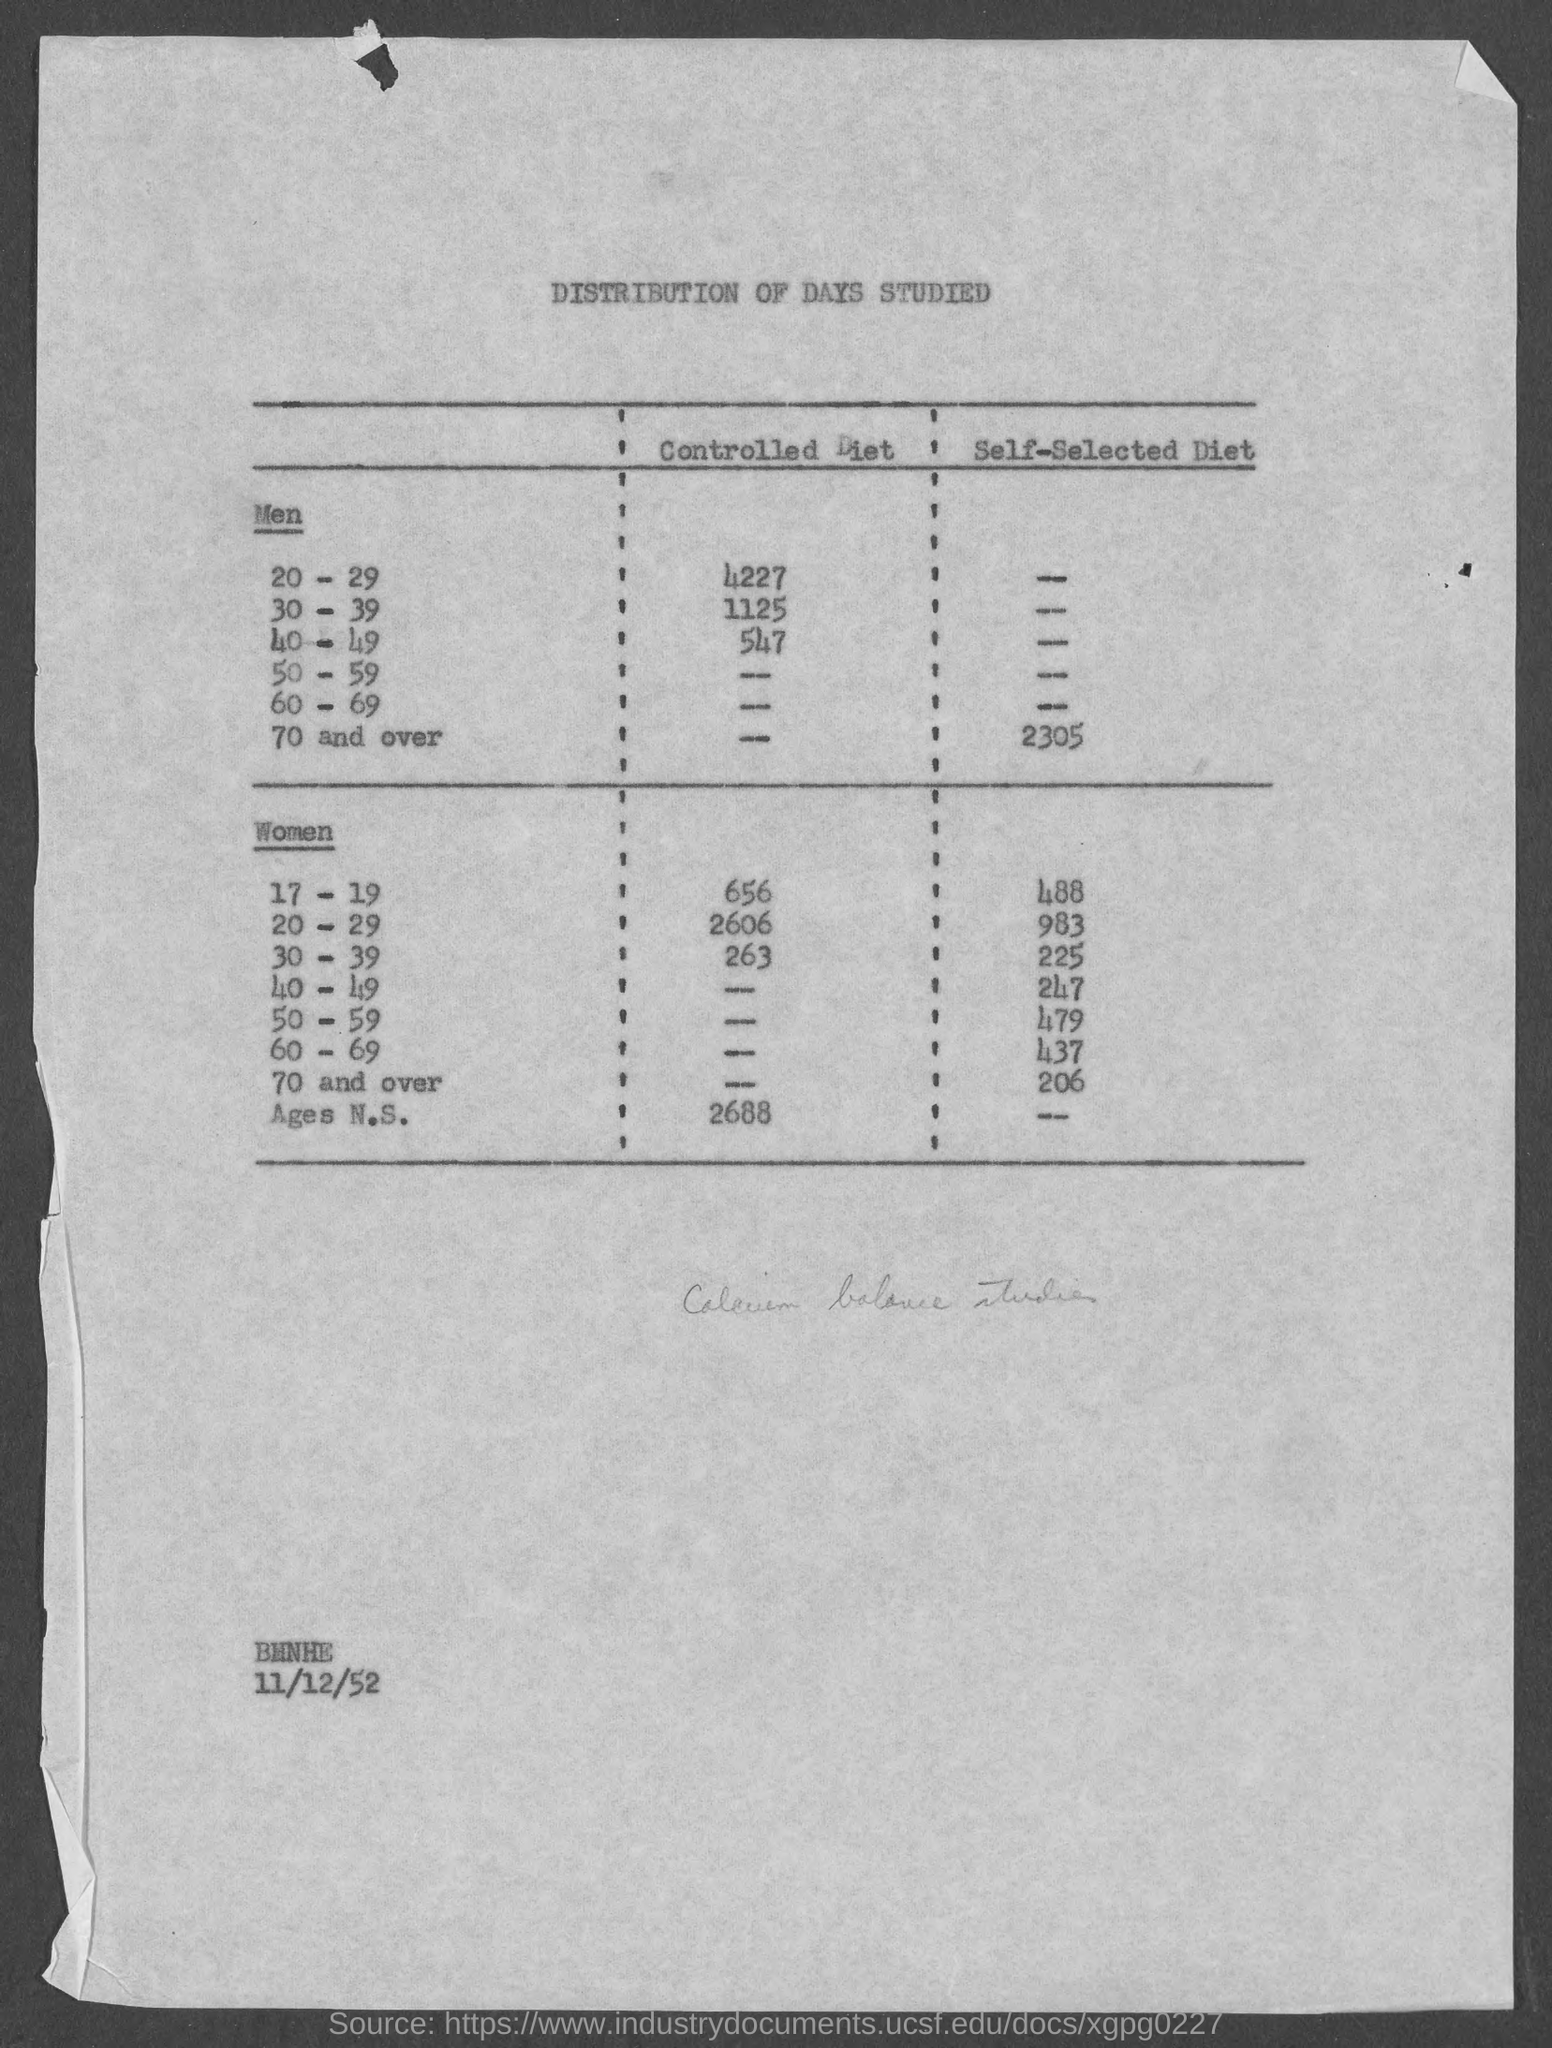Mention a couple of crucial points in this snapshot. The self-selected diet for women aged 40-49 is 247. The recommended daily dietary intake for women aged 60-69 who are self-selecting their diet is 437 calories. The title of the document is 'The Distribution of Days Studied.' A self-selected diet for women aged 30-39 is typically 225 calories per day. The value for a controlled diet for men aged 20-29 is 4227 calories per day, according to a specific nutritional guideline. 